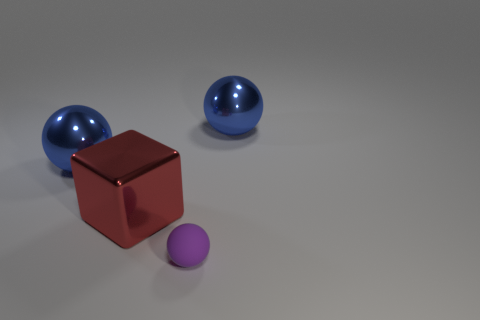Subtract all purple cylinders. How many blue spheres are left? 2 Add 4 shiny things. How many objects exist? 8 Subtract 1 balls. How many balls are left? 2 Subtract all cubes. How many objects are left? 3 Add 4 green shiny cylinders. How many green shiny cylinders exist? 4 Subtract 0 yellow blocks. How many objects are left? 4 Subtract all big red cubes. Subtract all purple objects. How many objects are left? 2 Add 2 red things. How many red things are left? 3 